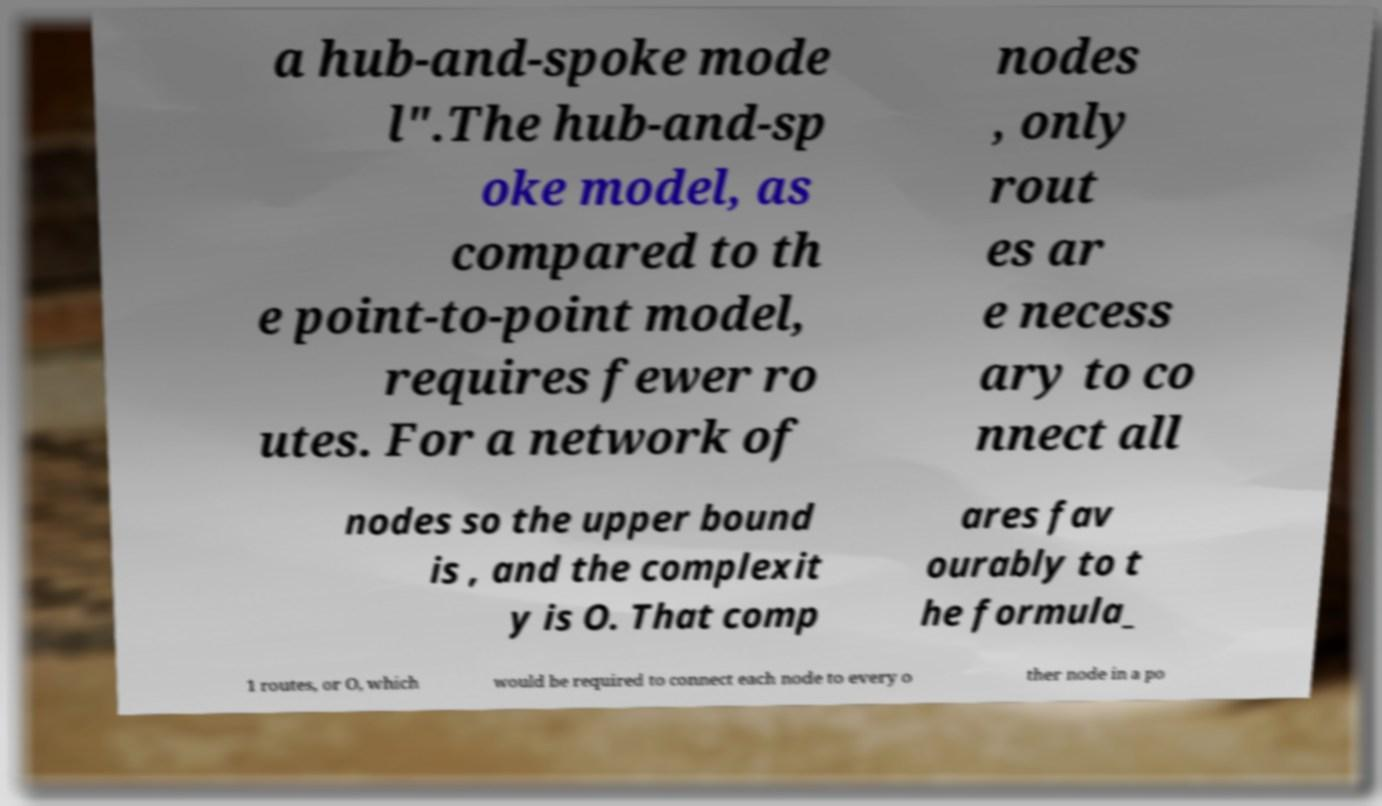Can you read and provide the text displayed in the image?This photo seems to have some interesting text. Can you extract and type it out for me? a hub-and-spoke mode l".The hub-and-sp oke model, as compared to th e point-to-point model, requires fewer ro utes. For a network of nodes , only rout es ar e necess ary to co nnect all nodes so the upper bound is , and the complexit y is O. That comp ares fav ourably to t he formula_ 1 routes, or O, which would be required to connect each node to every o ther node in a po 